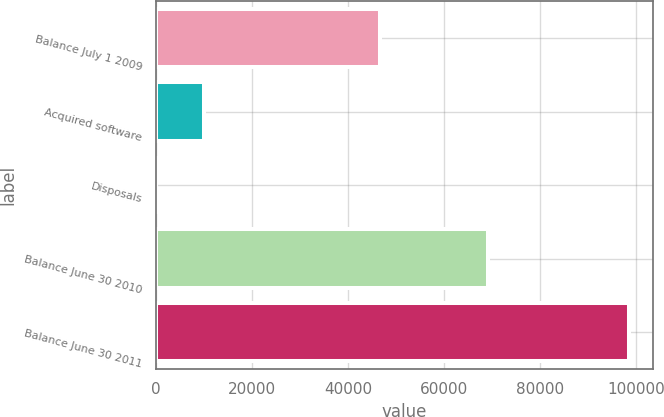Convert chart. <chart><loc_0><loc_0><loc_500><loc_500><bar_chart><fcel>Balance July 1 2009<fcel>Acquired software<fcel>Disposals<fcel>Balance June 30 2010<fcel>Balance June 30 2011<nl><fcel>46592<fcel>9876.6<fcel>16<fcel>69228<fcel>98622<nl></chart> 